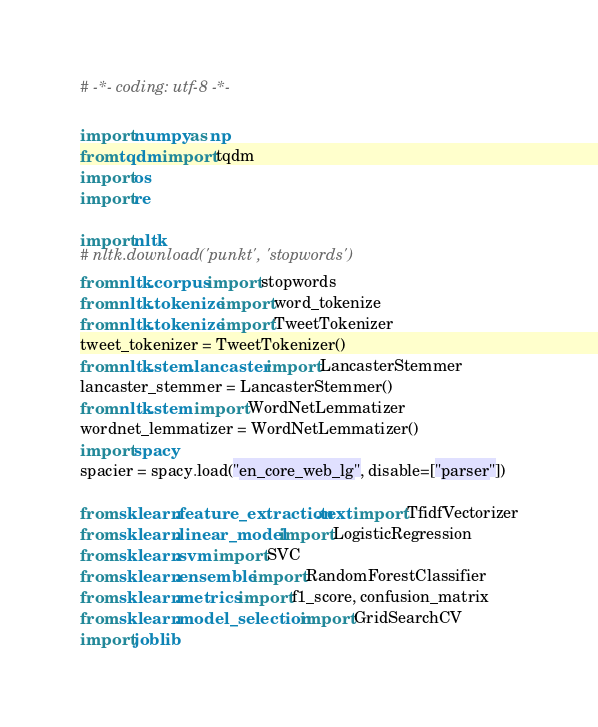Convert code to text. <code><loc_0><loc_0><loc_500><loc_500><_Python_># -*- coding: utf-8 -*-

import numpy as np
from tqdm import tqdm
import os
import re

import nltk
# nltk.download('punkt', 'stopwords')
from nltk.corpus import stopwords
from nltk.tokenize import word_tokenize
from nltk.tokenize import TweetTokenizer
tweet_tokenizer = TweetTokenizer()
from nltk.stem.lancaster import LancasterStemmer
lancaster_stemmer = LancasterStemmer()
from nltk.stem import WordNetLemmatizer
wordnet_lemmatizer = WordNetLemmatizer()
import spacy
spacier = spacy.load("en_core_web_lg", disable=["parser"])

from sklearn.feature_extraction.text import TfidfVectorizer
from sklearn.linear_model import LogisticRegression
from sklearn.svm import SVC
from sklearn.ensemble import RandomForestClassifier
from sklearn.metrics import f1_score, confusion_matrix
from sklearn.model_selection import GridSearchCV
import joblib</code> 